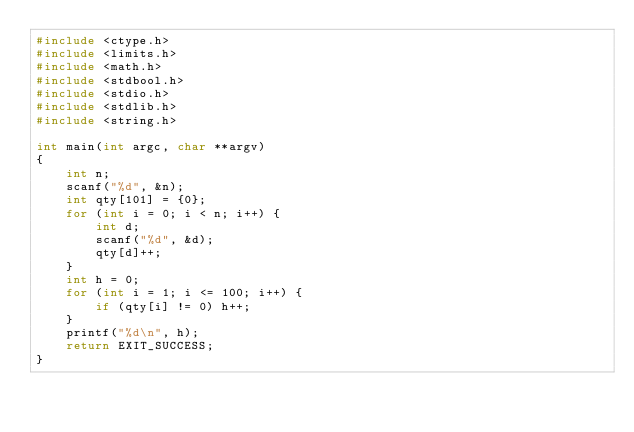<code> <loc_0><loc_0><loc_500><loc_500><_C_>#include <ctype.h>
#include <limits.h>
#include <math.h>
#include <stdbool.h>
#include <stdio.h>
#include <stdlib.h>
#include <string.h>

int main(int argc, char **argv)
{
    int n;
    scanf("%d", &n);
    int qty[101] = {0};
    for (int i = 0; i < n; i++) {
        int d;
        scanf("%d", &d);
        qty[d]++;
    }
    int h = 0;
    for (int i = 1; i <= 100; i++) {
        if (qty[i] != 0) h++;
    }
    printf("%d\n", h);
    return EXIT_SUCCESS;
}
</code> 